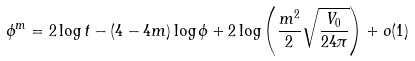Convert formula to latex. <formula><loc_0><loc_0><loc_500><loc_500>\phi ^ { m } = 2 \log t - ( 4 - 4 m ) \log \phi + 2 \log \left ( \frac { m ^ { 2 } } { 2 } \sqrt { \frac { V _ { 0 } } { 2 4 \pi } } \right ) + o ( 1 )</formula> 